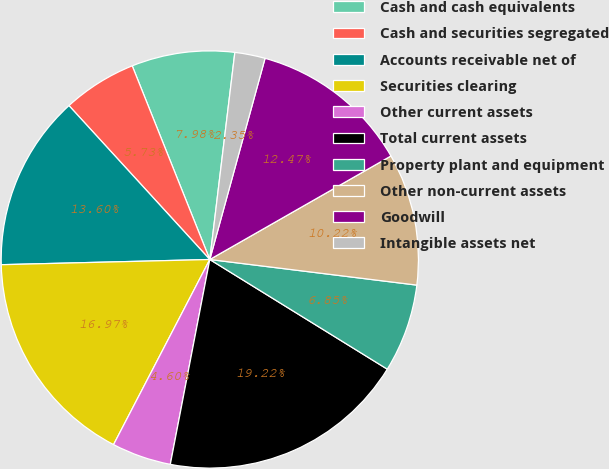Convert chart to OTSL. <chart><loc_0><loc_0><loc_500><loc_500><pie_chart><fcel>Cash and cash equivalents<fcel>Cash and securities segregated<fcel>Accounts receivable net of<fcel>Securities clearing<fcel>Other current assets<fcel>Total current assets<fcel>Property plant and equipment<fcel>Other non-current assets<fcel>Goodwill<fcel>Intangible assets net<nl><fcel>7.98%<fcel>5.73%<fcel>13.6%<fcel>16.97%<fcel>4.6%<fcel>19.22%<fcel>6.85%<fcel>10.22%<fcel>12.47%<fcel>2.35%<nl></chart> 